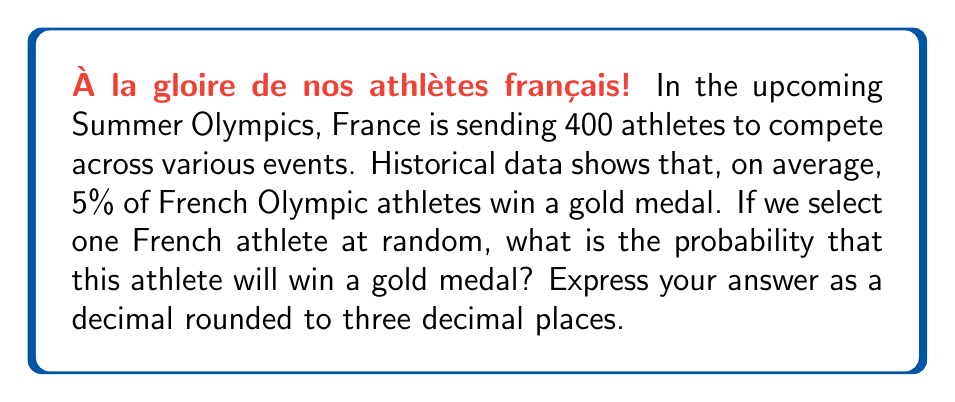Give your solution to this math problem. Let's approach this problem step by step:

1) We are given two important pieces of information:
   - There are 400 French athletes in total
   - On average, 5% of French athletes win a gold medal

2) To calculate the probability, we need to determine:
   $$\text{Probability} = \frac{\text{Number of favorable outcomes}}{\text{Total number of possible outcomes}}$$

3) In this case:
   - The total number of possible outcomes is the total number of French athletes: 400
   - The number of favorable outcomes (gold medal winners) is 5% of 400

4) Let's calculate the number of favorable outcomes:
   $$5\% \text{ of } 400 = 0.05 \times 400 = 20$$

5) Now we can plug these numbers into our probability formula:
   $$\text{Probability} = \frac{20}{400} = 0.05$$

6) The question asks for the answer rounded to three decimal places, but 0.05 is already in that form.

Thus, the probability of selecting a French athlete who will win a gold medal is 0.050 or 5%.
Answer: 0.050 